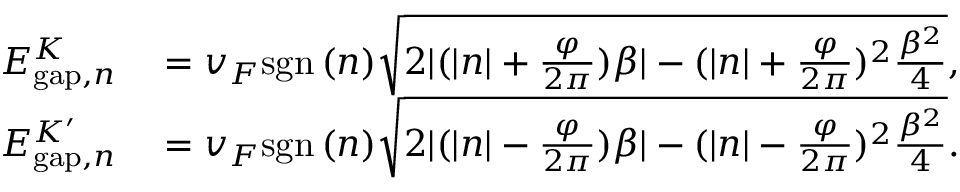<formula> <loc_0><loc_0><loc_500><loc_500>\begin{array} { r l } { E _ { g a p , n } ^ { K } } & = v _ { F } s g n \, ( n ) \sqrt { 2 | ( | n | + \frac { \varphi } { 2 \pi } ) \beta | - ( | n | + \frac { \varphi } { 2 \pi } ) ^ { 2 } \frac { \beta ^ { 2 } } { 4 } } , } \\ { E _ { g a p , n } ^ { K ^ { \prime } } } & = v _ { F } s g n \, ( n ) \sqrt { 2 | ( | n | - \frac { \varphi } { 2 \pi } ) \beta | - ( | n | - \frac { \varphi } { 2 \pi } ) ^ { 2 } \frac { \beta ^ { 2 } } { 4 } } . } \end{array}</formula> 